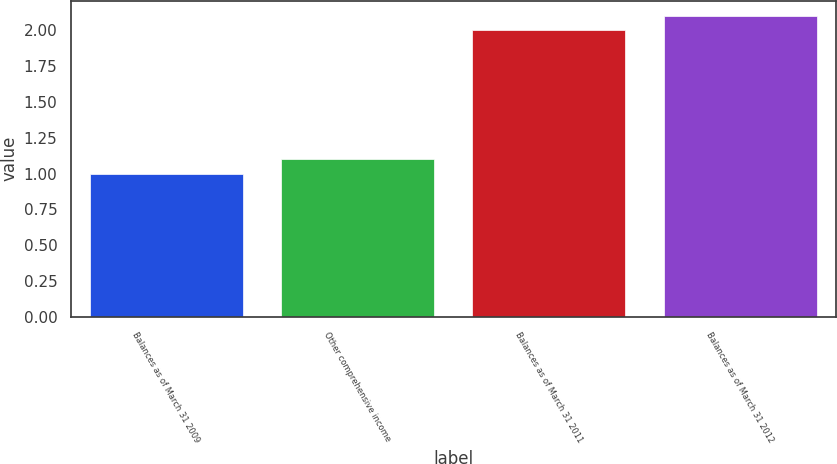<chart> <loc_0><loc_0><loc_500><loc_500><bar_chart><fcel>Balances as of March 31 2009<fcel>Other comprehensive income<fcel>Balances as of March 31 2011<fcel>Balances as of March 31 2012<nl><fcel>1<fcel>1.1<fcel>2<fcel>2.1<nl></chart> 